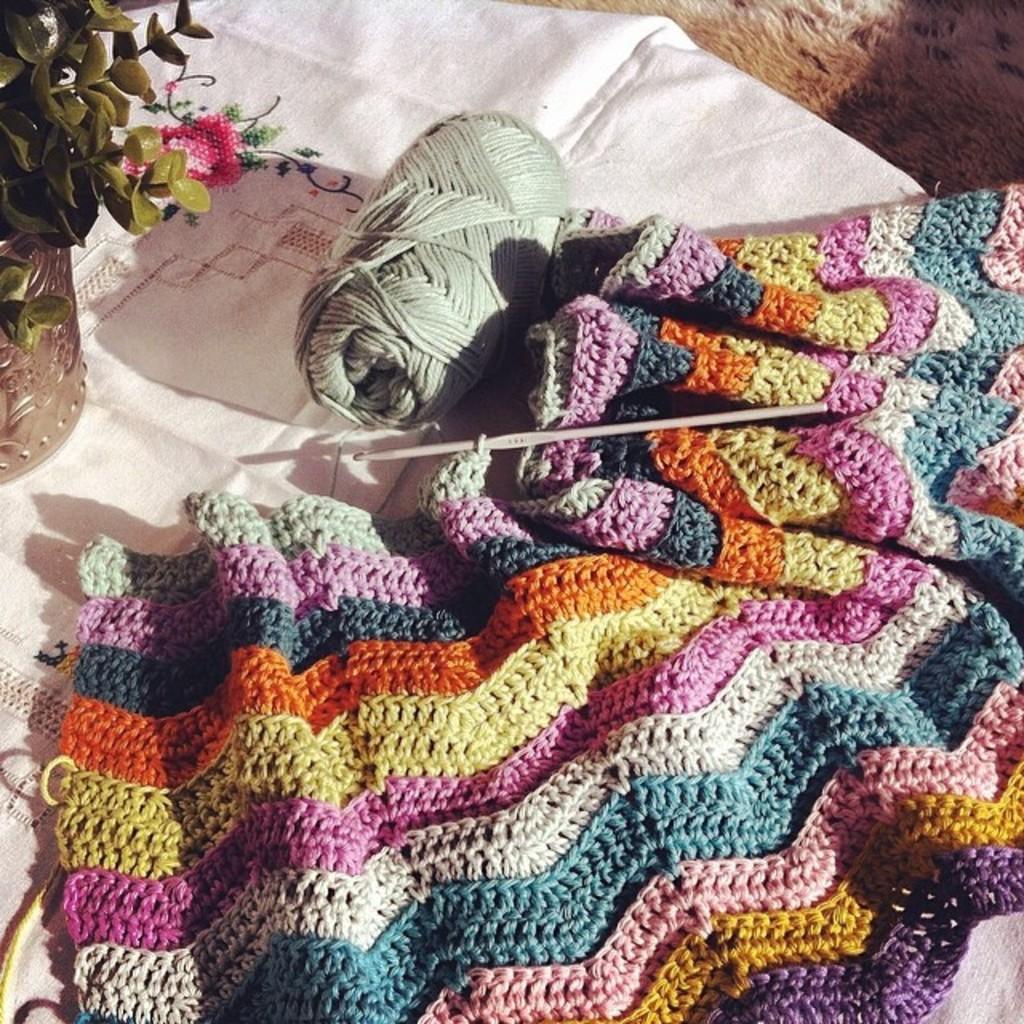Could you give a brief overview of what you see in this image? In this image I can see a wool cloth, needle, thread, houseplant, cloth may be on the floor. This image is taken may be in a room. 